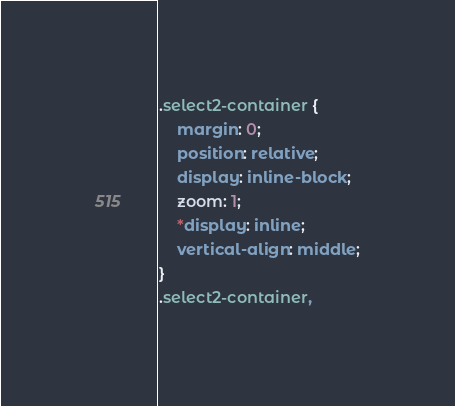Convert code to text. <code><loc_0><loc_0><loc_500><loc_500><_CSS_>.select2-container {
    margin: 0;
    position: relative;
    display: inline-block;
    zoom: 1;
    *display: inline;
    vertical-align: middle;
}
.select2-container,</code> 